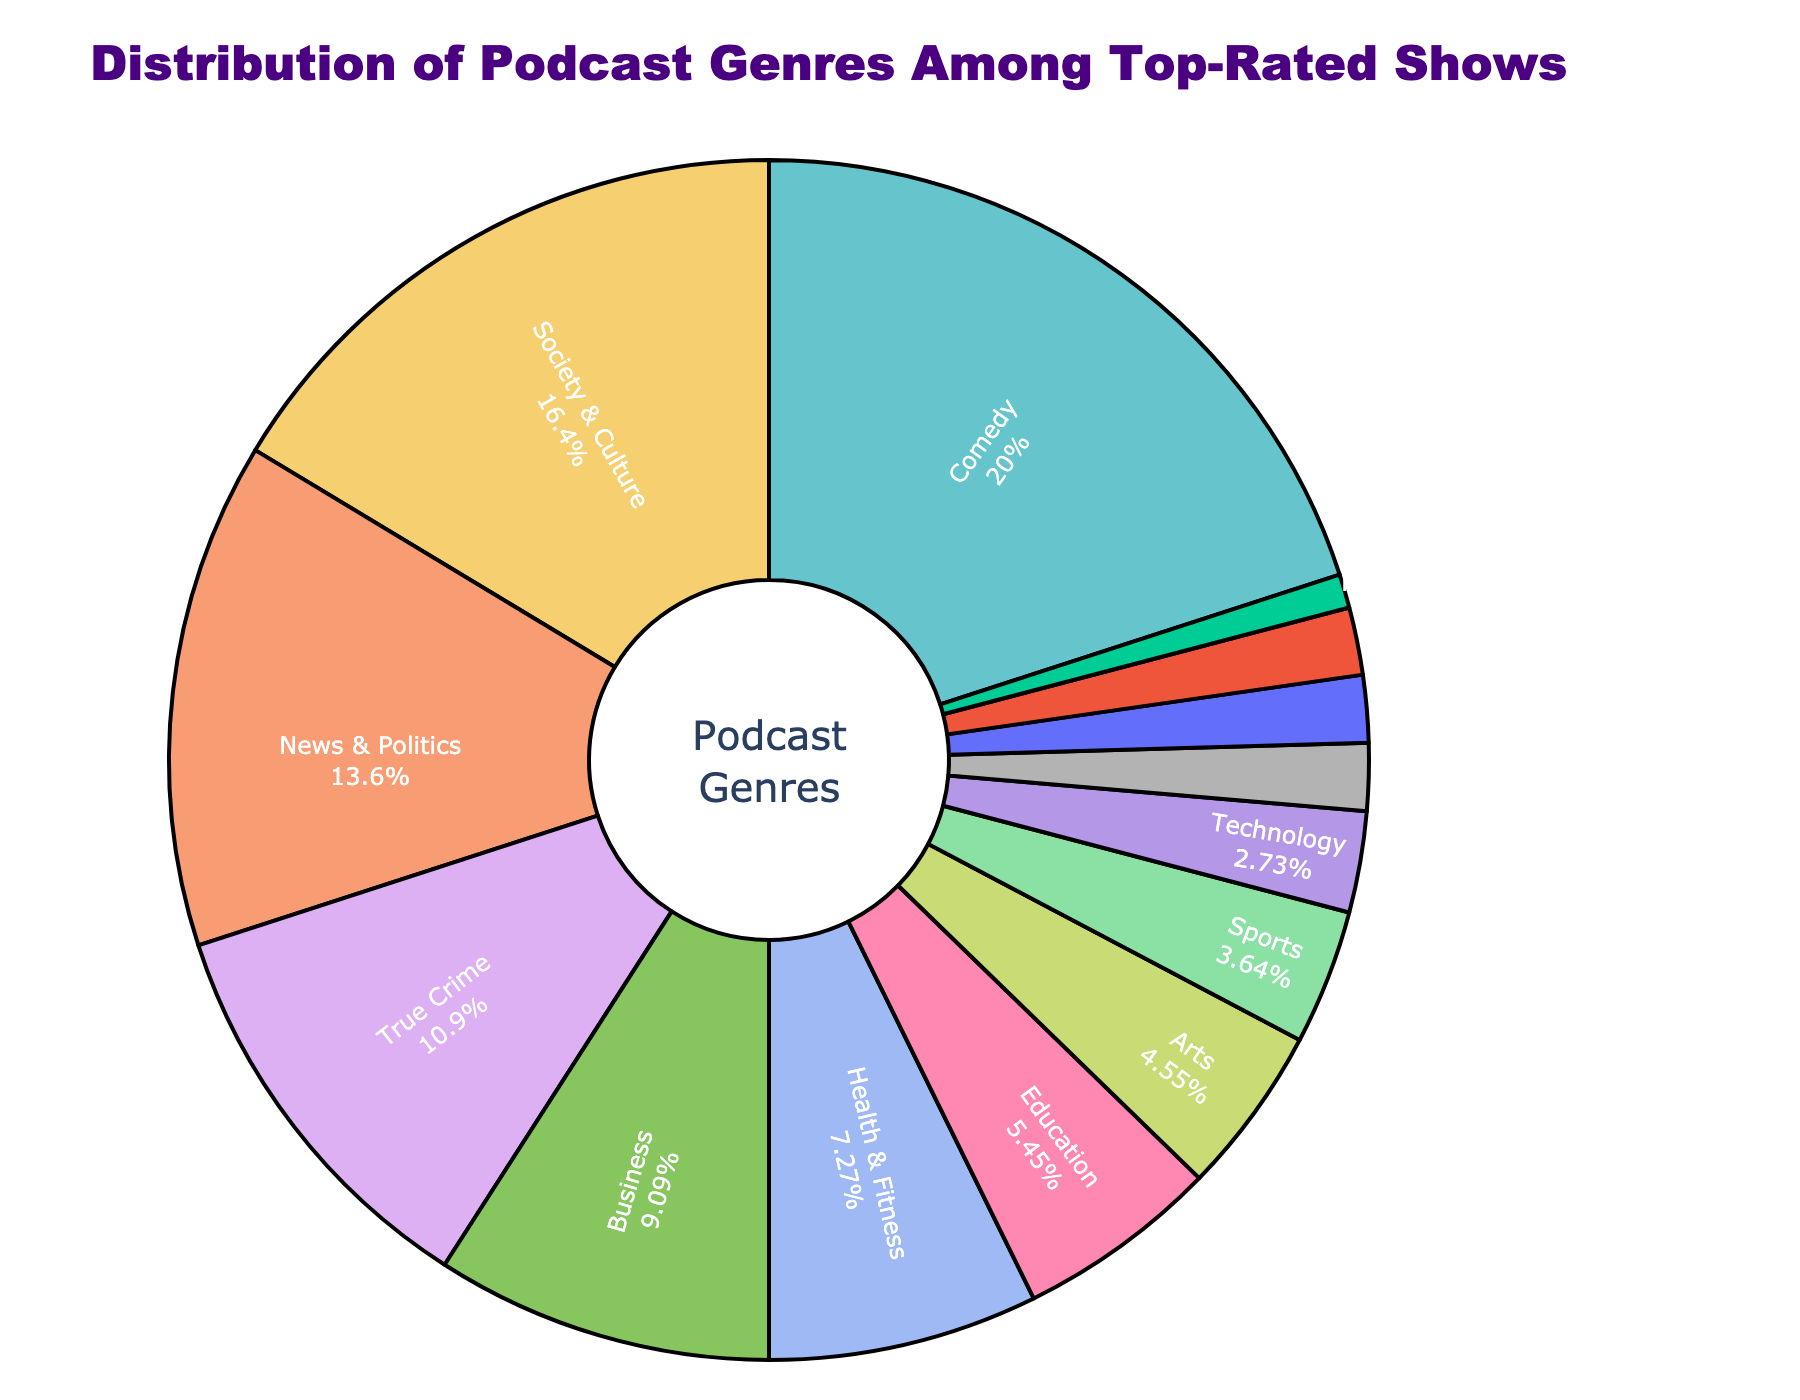What's the most popular podcast genre among the top-rated shows? The pie chart shows various genres as slices with their corresponding percentages. The genre with the largest slice is the most popular. The "Comedy" genre has the largest slice with a 22% share.
Answer: Comedy Which genre has the smallest share among the top-rated shows? To find the smallest share, look for the genre with the smallest slice in the pie chart. "History" has the smallest slice with a 1% share.
Answer: History Comparing "Society & Culture" and "Sports" genres, which one has a greater share, and by how much? "Society & Culture" has an 18% share, and "Sports" has a 4% share. So, the difference is 18% - 4% = 14%.
Answer: Society & Culture, by 14% If you sum the percentages of the "Health & Fitness" and "Education" genres, what percentage do you get? "Health & Fitness" has an 8% share and "Education" has a 6% share. Adding them together gives 8% + 6% = 14%.
Answer: 14% What is the combined percentage share of "News & Politics," "True Crime," and "Business" genres? "News & Politics" has 15%, "True Crime" has 12%, and "Business" has 10%. Adding them gives 15% + 12% + 10% = 37%.
Answer: 37% How does the percentage of the "Technology" genre compare to the "Science" genre? The "Technology" genre has a 3% share and the "Science" genre has a 2% share. The "Technology" genre has 1% more than the "Science" genre.
Answer: Technology, by 1% What is the middle value when you arrange the percentages from highest to lowest? The percentages in descending order are 22, 18, 15, 12, 10, 8, 6, 5, 4, 3, 2, 2, 2, 1. The middle value (7th) is the percentage share of "Education," which is 6%.
Answer: 6% How many genres have a percentage share of 5% or less? The genres with 5% or less are "Arts (5%)," "Sports (4%)," "Technology (3%)," "Science (2%)," "Music (2%)," "Religion & Spirituality (2%)," and "History (1%)". There are 7 such genres.
Answer: 7 What is the total percentage of genres that have a share higher than "News & Politics"? The genres with a higher share than "News & Politics" (15%) are "Comedy (22%)" and "Society & Culture (18%)". So, the total percentage is 22% + 18% = 40%.
Answer: 40% 